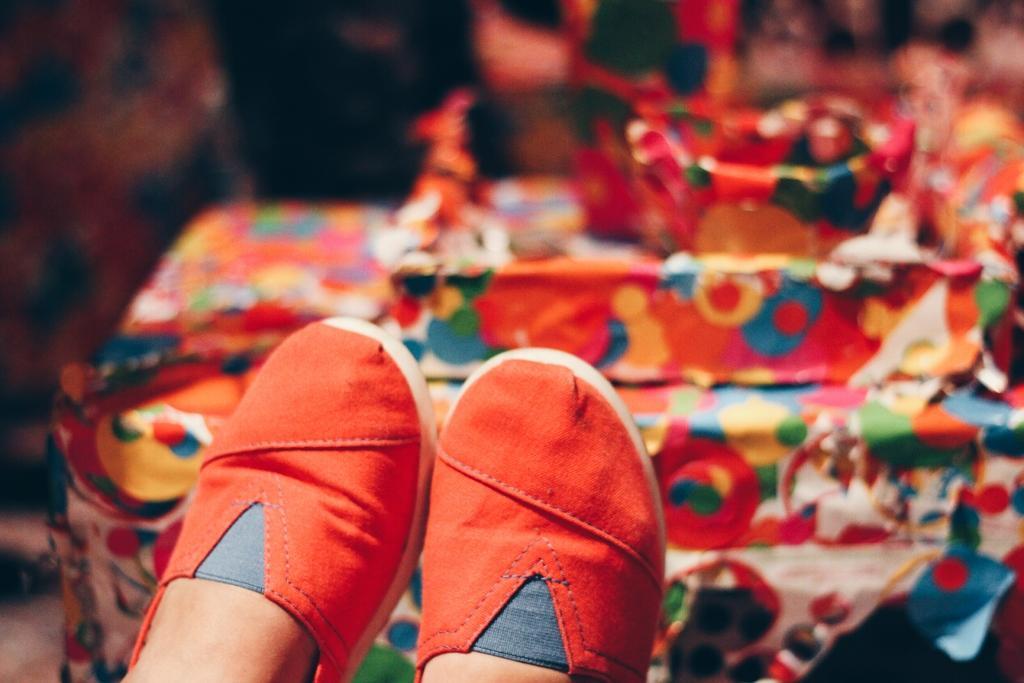Describe this image in one or two sentences. In the foreground of this picture, there are two shoes to the legs of a person. In the background, there is a table and few objects on it. 